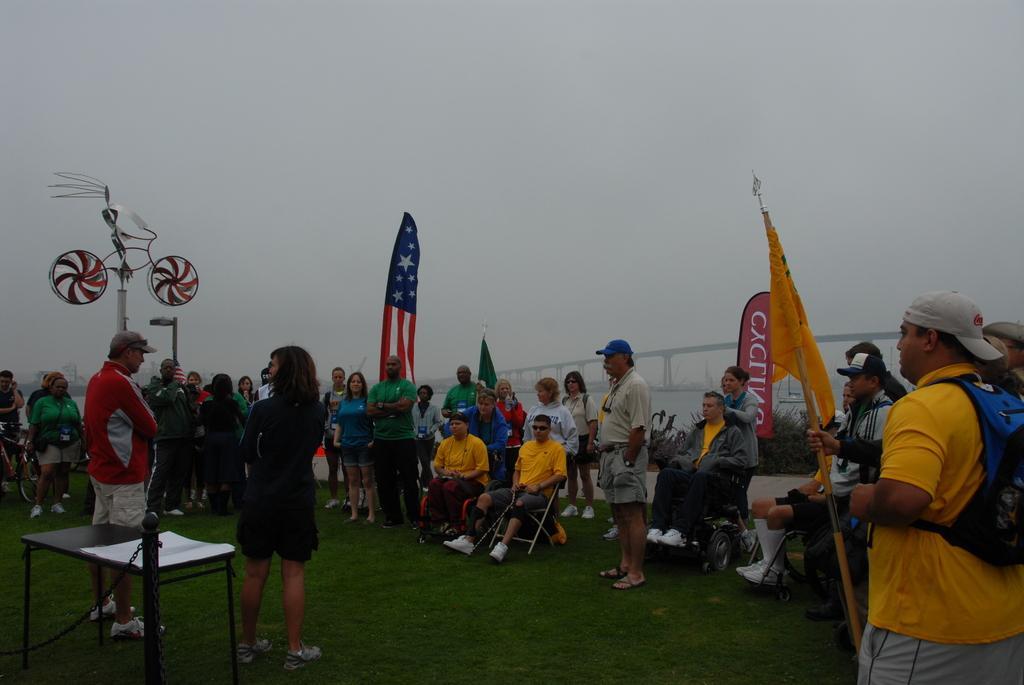Could you give a brief overview of what you see in this image? Here we can see group of people, flags, table, bicycle, and a banner. In the background we can see a bridge and sky. 